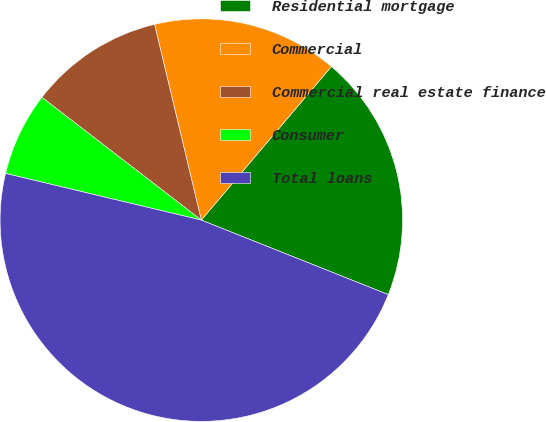Convert chart. <chart><loc_0><loc_0><loc_500><loc_500><pie_chart><fcel>Residential mortgage<fcel>Commercial<fcel>Commercial real estate finance<fcel>Consumer<fcel>Total loans<nl><fcel>19.85%<fcel>14.92%<fcel>10.82%<fcel>6.72%<fcel>47.69%<nl></chart> 